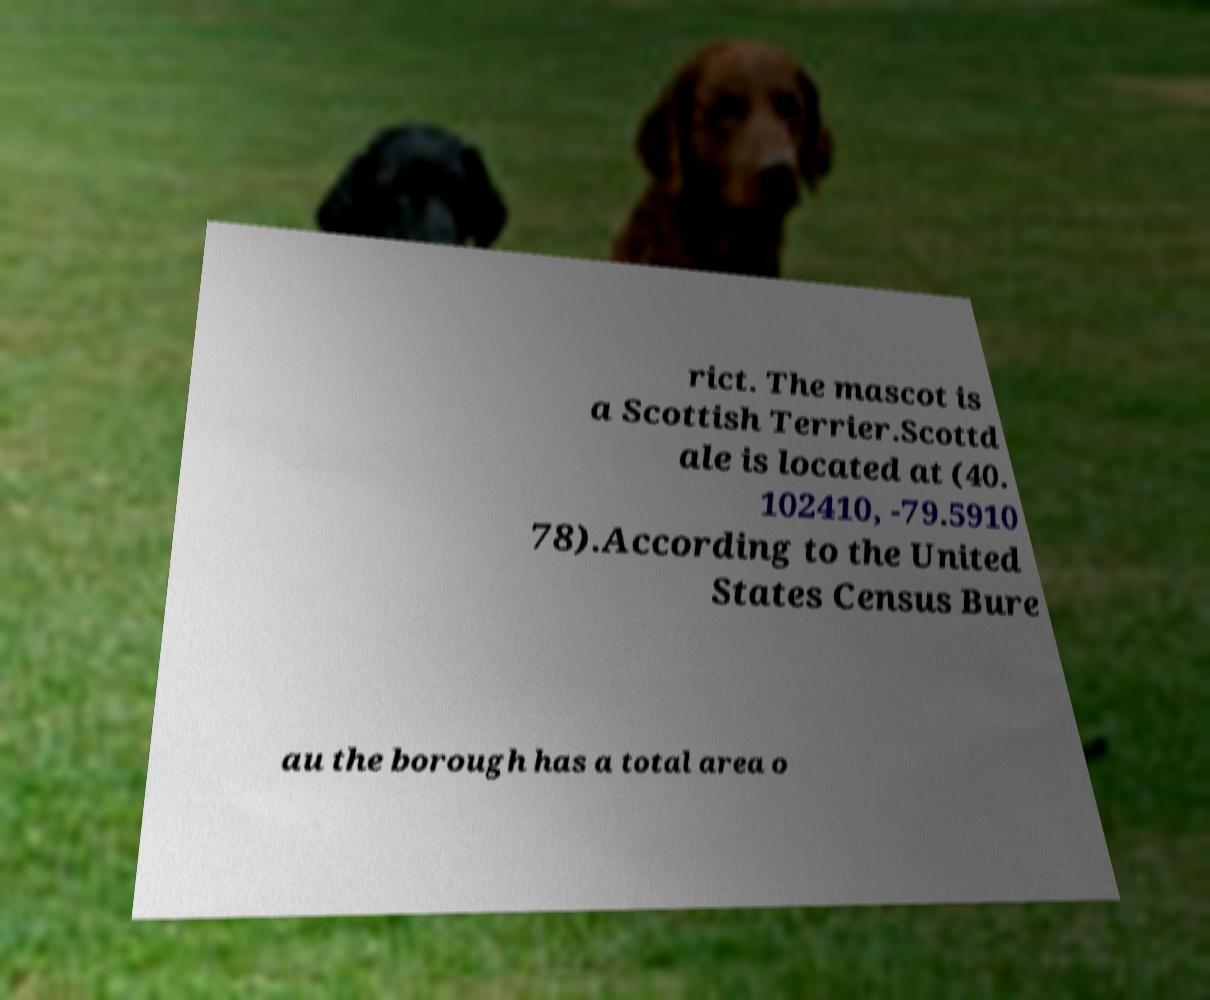For documentation purposes, I need the text within this image transcribed. Could you provide that? rict. The mascot is a Scottish Terrier.Scottd ale is located at (40. 102410, -79.5910 78).According to the United States Census Bure au the borough has a total area o 